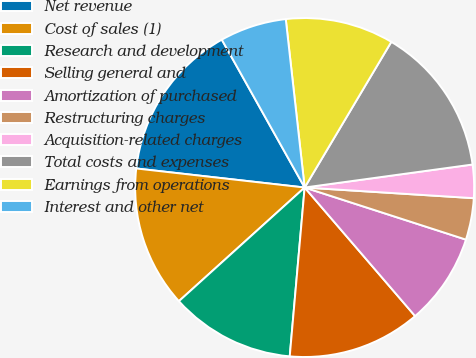Convert chart. <chart><loc_0><loc_0><loc_500><loc_500><pie_chart><fcel>Net revenue<fcel>Cost of sales (1)<fcel>Research and development<fcel>Selling general and<fcel>Amortization of purchased<fcel>Restructuring charges<fcel>Acquisition-related charges<fcel>Total costs and expenses<fcel>Earnings from operations<fcel>Interest and other net<nl><fcel>15.08%<fcel>13.49%<fcel>11.9%<fcel>12.7%<fcel>8.73%<fcel>3.97%<fcel>3.17%<fcel>14.29%<fcel>10.32%<fcel>6.35%<nl></chart> 